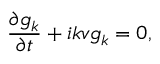Convert formula to latex. <formula><loc_0><loc_0><loc_500><loc_500>\frac { \partial g _ { k } } { \partial t } + i k v g _ { k } = 0 ,</formula> 